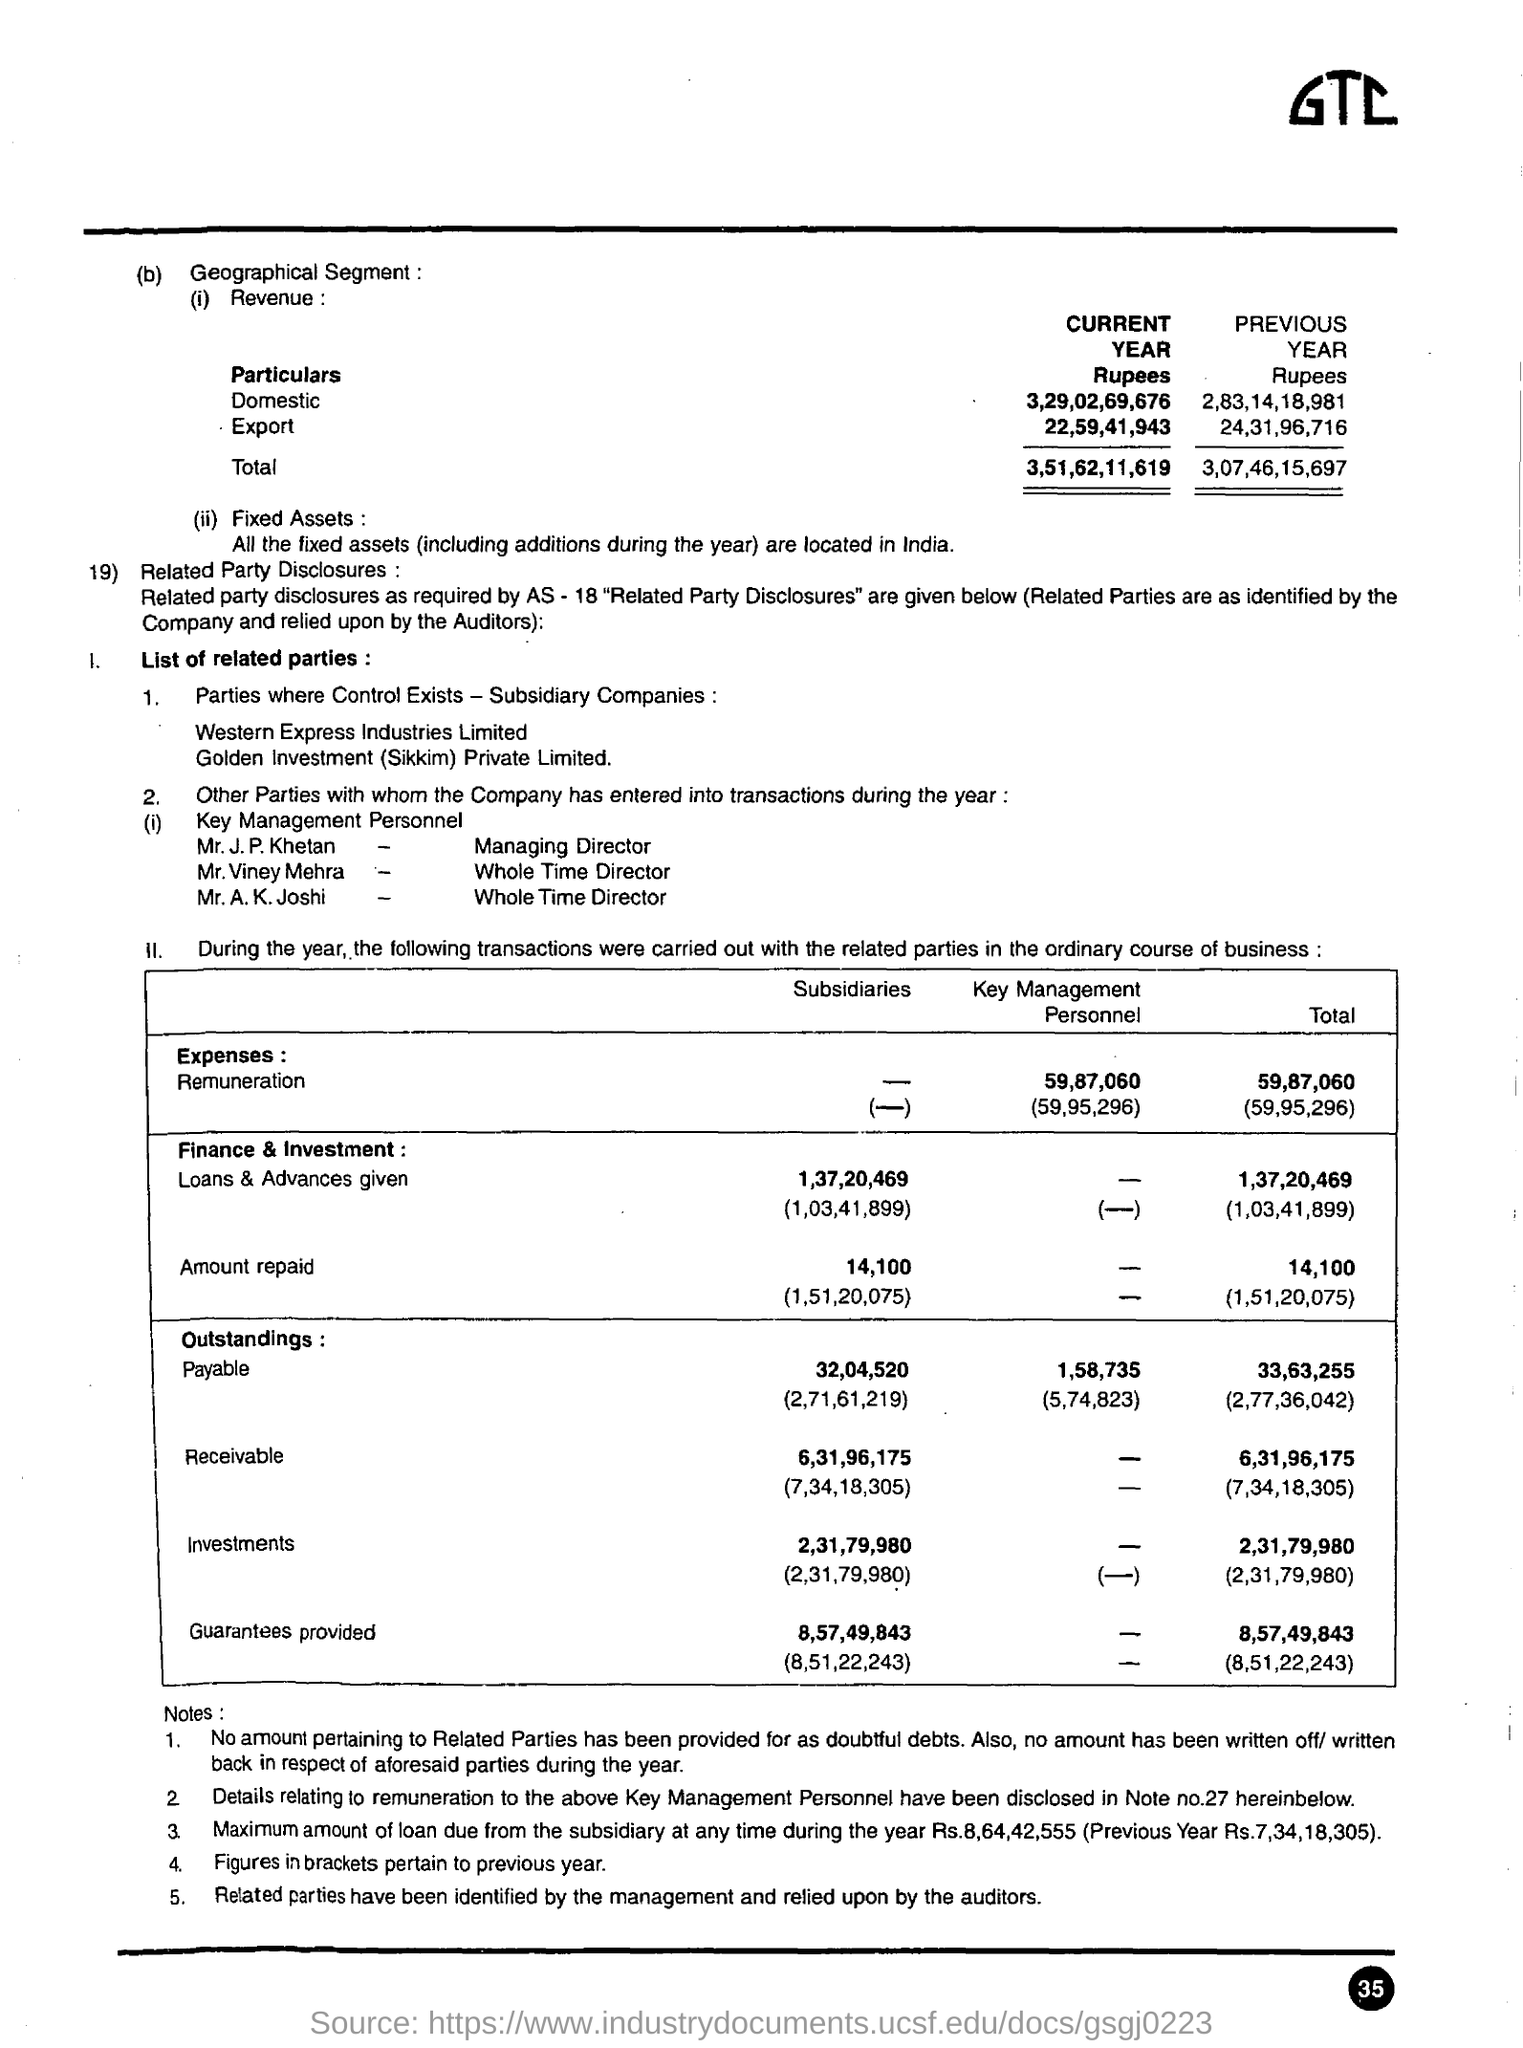Highlight a few significant elements in this photo. The total revenue for the current year is 3,51,62,11,619. The subsidiaries repaid a total of approximately 14,100 in how much amount is repaid in the subsidiaries ? The outstanding payable in the subsidiaries is 32,04,520. 